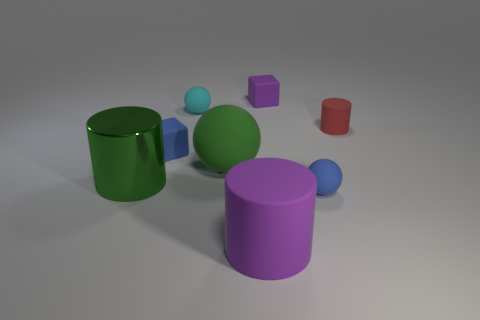Add 1 tiny cyan matte objects. How many objects exist? 9 Subtract all cubes. How many objects are left? 6 Subtract all small cylinders. Subtract all small red matte things. How many objects are left? 6 Add 1 purple objects. How many purple objects are left? 3 Add 3 small balls. How many small balls exist? 5 Subtract 1 blue blocks. How many objects are left? 7 